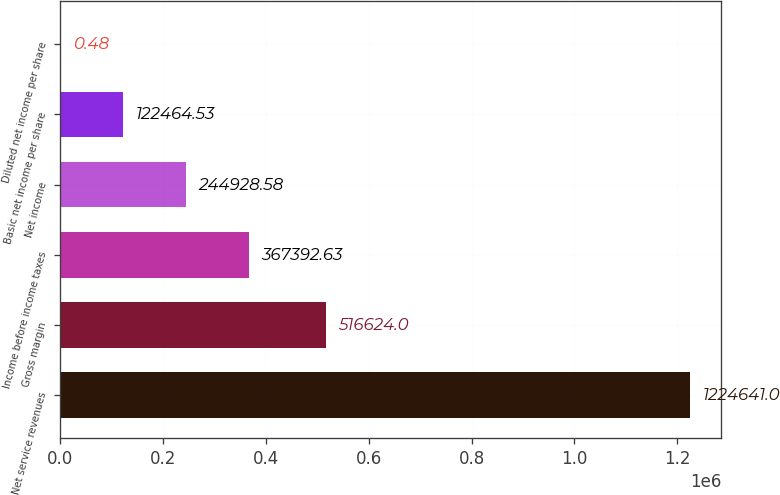Convert chart to OTSL. <chart><loc_0><loc_0><loc_500><loc_500><bar_chart><fcel>Net service revenues<fcel>Gross margin<fcel>Income before income taxes<fcel>Net income<fcel>Basic net income per share<fcel>Diluted net income per share<nl><fcel>1.22464e+06<fcel>516624<fcel>367393<fcel>244929<fcel>122465<fcel>0.48<nl></chart> 